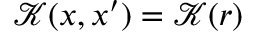Convert formula to latex. <formula><loc_0><loc_0><loc_500><loc_500>\mathcal { K } ( x , x ^ { \prime } ) = \mathcal { K } ( r )</formula> 